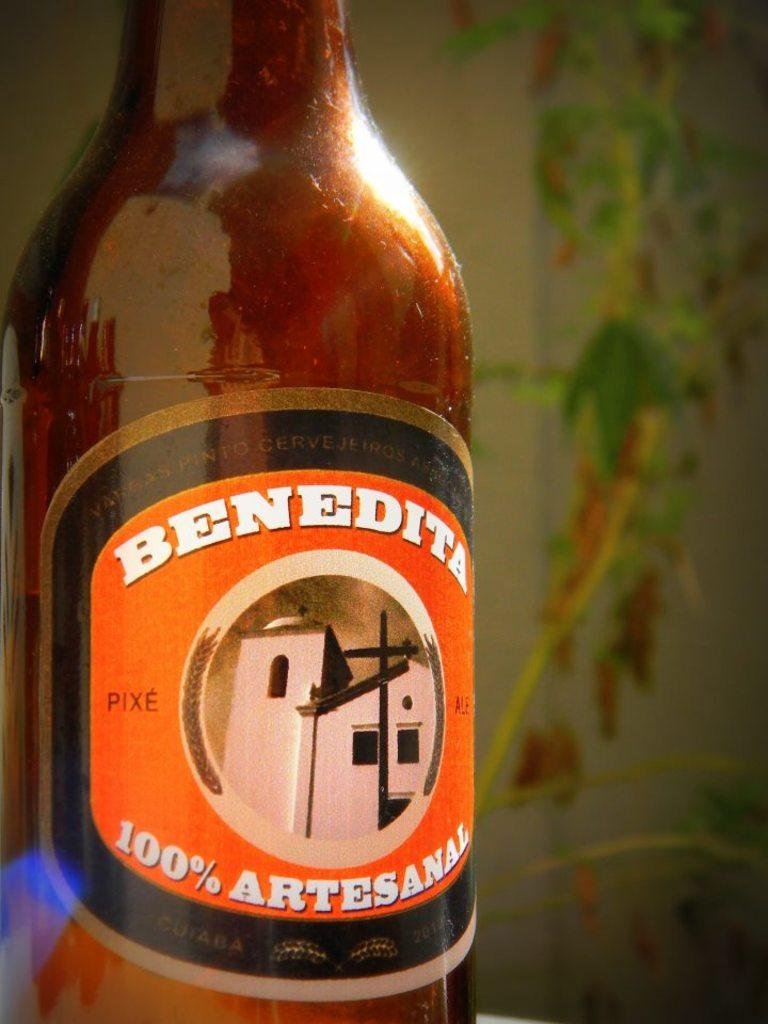<image>
Summarize the visual content of the image. Close up of a bottle of Benedita 100 percent artesanal beverage. 